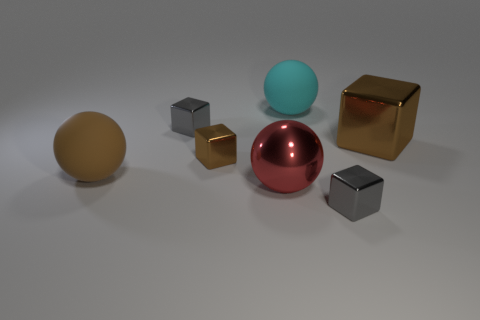Subtract all cyan cubes. Subtract all brown cylinders. How many cubes are left? 4 Add 2 rubber cylinders. How many objects exist? 9 Subtract all balls. How many objects are left? 4 Subtract 0 green cylinders. How many objects are left? 7 Subtract all brown shiny cubes. Subtract all gray things. How many objects are left? 3 Add 6 tiny gray things. How many tiny gray things are left? 8 Add 7 small cubes. How many small cubes exist? 10 